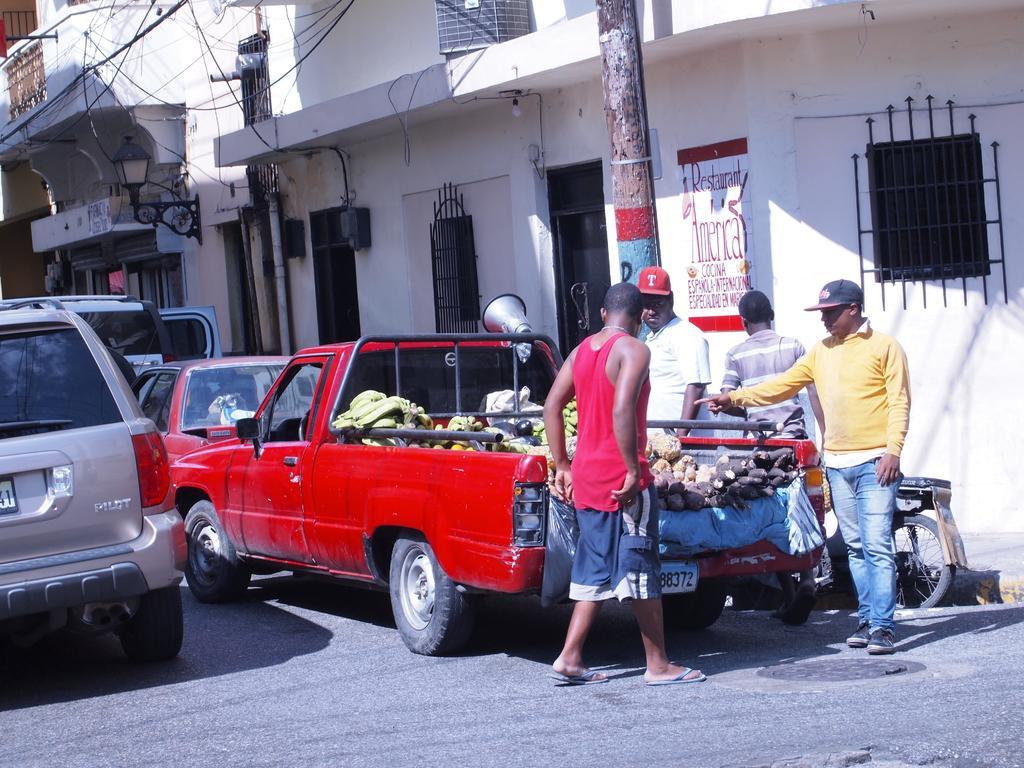In one or two sentences, can you explain what this image depicts? In this picture there are three people standing and there is a man walking. There are vehicles on the road. At the back there are buildings and there is text on the wall and there is a light and there is a pipe on the wall and there is a pole. At the bottom there is a manhole on the road. 